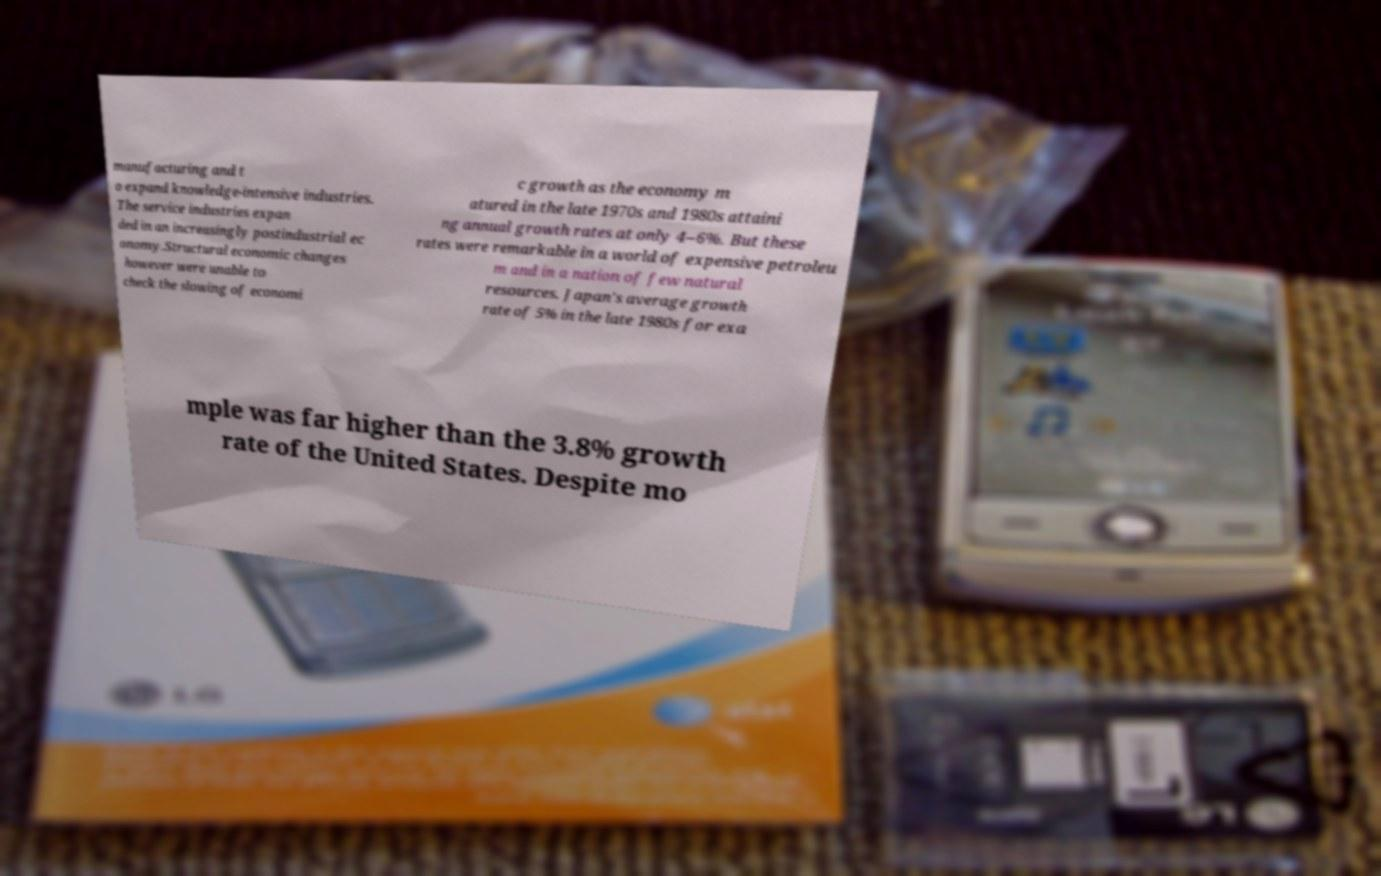Please identify and transcribe the text found in this image. manufacturing and t o expand knowledge-intensive industries. The service industries expan ded in an increasingly postindustrial ec onomy.Structural economic changes however were unable to check the slowing of economi c growth as the economy m atured in the late 1970s and 1980s attaini ng annual growth rates at only 4–6%. But these rates were remarkable in a world of expensive petroleu m and in a nation of few natural resources. Japan's average growth rate of 5% in the late 1980s for exa mple was far higher than the 3.8% growth rate of the United States. Despite mo 